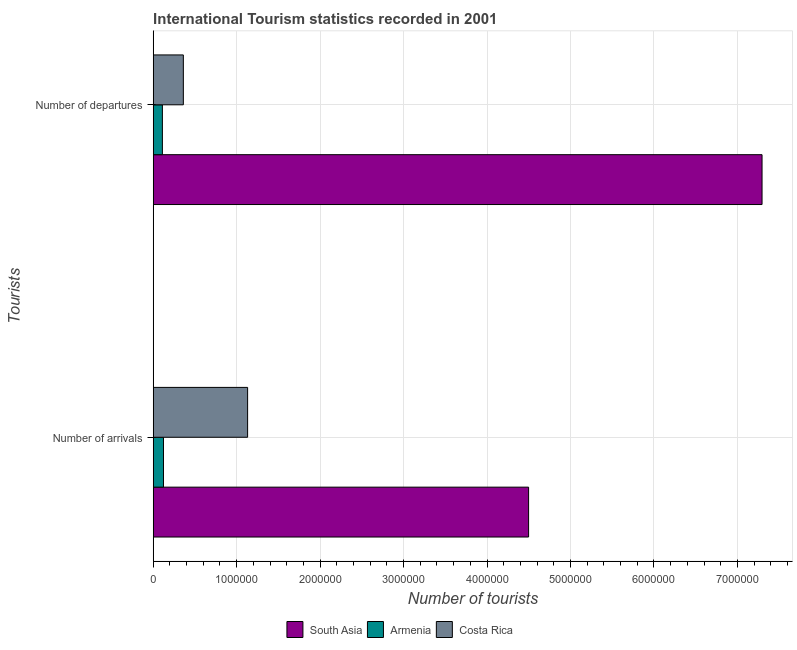Are the number of bars on each tick of the Y-axis equal?
Offer a terse response. Yes. How many bars are there on the 1st tick from the top?
Provide a succinct answer. 3. How many bars are there on the 1st tick from the bottom?
Provide a succinct answer. 3. What is the label of the 1st group of bars from the top?
Your response must be concise. Number of departures. What is the number of tourist arrivals in South Asia?
Offer a terse response. 4.50e+06. Across all countries, what is the maximum number of tourist departures?
Offer a terse response. 7.29e+06. Across all countries, what is the minimum number of tourist arrivals?
Your response must be concise. 1.23e+05. In which country was the number of tourist departures maximum?
Your response must be concise. South Asia. In which country was the number of tourist arrivals minimum?
Provide a succinct answer. Armenia. What is the total number of tourist arrivals in the graph?
Give a very brief answer. 5.75e+06. What is the difference between the number of tourist departures in Costa Rica and that in Armenia?
Make the answer very short. 2.51e+05. What is the difference between the number of tourist arrivals in Costa Rica and the number of tourist departures in South Asia?
Offer a very short reply. -6.16e+06. What is the average number of tourist departures per country?
Make the answer very short. 2.59e+06. What is the difference between the number of tourist departures and number of tourist arrivals in Armenia?
Make the answer very short. -1.30e+04. What is the ratio of the number of tourist arrivals in Costa Rica to that in Armenia?
Make the answer very short. 9.2. Is the number of tourist departures in Costa Rica less than that in Armenia?
Make the answer very short. No. In how many countries, is the number of tourist arrivals greater than the average number of tourist arrivals taken over all countries?
Your response must be concise. 1. What does the 2nd bar from the top in Number of arrivals represents?
Your answer should be very brief. Armenia. How many bars are there?
Ensure brevity in your answer.  6. Are all the bars in the graph horizontal?
Your answer should be compact. Yes. How many countries are there in the graph?
Your answer should be compact. 3. Does the graph contain any zero values?
Your answer should be compact. No. Where does the legend appear in the graph?
Ensure brevity in your answer.  Bottom center. What is the title of the graph?
Your answer should be very brief. International Tourism statistics recorded in 2001. Does "Monaco" appear as one of the legend labels in the graph?
Make the answer very short. No. What is the label or title of the X-axis?
Give a very brief answer. Number of tourists. What is the label or title of the Y-axis?
Provide a short and direct response. Tourists. What is the Number of tourists of South Asia in Number of arrivals?
Offer a terse response. 4.50e+06. What is the Number of tourists of Armenia in Number of arrivals?
Your answer should be compact. 1.23e+05. What is the Number of tourists of Costa Rica in Number of arrivals?
Make the answer very short. 1.13e+06. What is the Number of tourists in South Asia in Number of departures?
Your answer should be compact. 7.29e+06. What is the Number of tourists in Costa Rica in Number of departures?
Offer a terse response. 3.61e+05. Across all Tourists, what is the maximum Number of tourists of South Asia?
Offer a terse response. 7.29e+06. Across all Tourists, what is the maximum Number of tourists of Armenia?
Ensure brevity in your answer.  1.23e+05. Across all Tourists, what is the maximum Number of tourists of Costa Rica?
Keep it short and to the point. 1.13e+06. Across all Tourists, what is the minimum Number of tourists in South Asia?
Your response must be concise. 4.50e+06. Across all Tourists, what is the minimum Number of tourists of Costa Rica?
Ensure brevity in your answer.  3.61e+05. What is the total Number of tourists in South Asia in the graph?
Your answer should be very brief. 1.18e+07. What is the total Number of tourists in Armenia in the graph?
Give a very brief answer. 2.33e+05. What is the total Number of tourists in Costa Rica in the graph?
Make the answer very short. 1.49e+06. What is the difference between the Number of tourists of South Asia in Number of arrivals and that in Number of departures?
Your answer should be very brief. -2.80e+06. What is the difference between the Number of tourists in Armenia in Number of arrivals and that in Number of departures?
Make the answer very short. 1.30e+04. What is the difference between the Number of tourists of Costa Rica in Number of arrivals and that in Number of departures?
Keep it short and to the point. 7.70e+05. What is the difference between the Number of tourists of South Asia in Number of arrivals and the Number of tourists of Armenia in Number of departures?
Your response must be concise. 4.39e+06. What is the difference between the Number of tourists of South Asia in Number of arrivals and the Number of tourists of Costa Rica in Number of departures?
Give a very brief answer. 4.14e+06. What is the difference between the Number of tourists in Armenia in Number of arrivals and the Number of tourists in Costa Rica in Number of departures?
Your answer should be compact. -2.38e+05. What is the average Number of tourists of South Asia per Tourists?
Your answer should be very brief. 5.90e+06. What is the average Number of tourists in Armenia per Tourists?
Your answer should be compact. 1.16e+05. What is the average Number of tourists of Costa Rica per Tourists?
Keep it short and to the point. 7.46e+05. What is the difference between the Number of tourists of South Asia and Number of tourists of Armenia in Number of arrivals?
Keep it short and to the point. 4.37e+06. What is the difference between the Number of tourists in South Asia and Number of tourists in Costa Rica in Number of arrivals?
Make the answer very short. 3.37e+06. What is the difference between the Number of tourists in Armenia and Number of tourists in Costa Rica in Number of arrivals?
Provide a short and direct response. -1.01e+06. What is the difference between the Number of tourists in South Asia and Number of tourists in Armenia in Number of departures?
Your answer should be compact. 7.18e+06. What is the difference between the Number of tourists in South Asia and Number of tourists in Costa Rica in Number of departures?
Give a very brief answer. 6.93e+06. What is the difference between the Number of tourists in Armenia and Number of tourists in Costa Rica in Number of departures?
Provide a succinct answer. -2.51e+05. What is the ratio of the Number of tourists in South Asia in Number of arrivals to that in Number of departures?
Offer a very short reply. 0.62. What is the ratio of the Number of tourists of Armenia in Number of arrivals to that in Number of departures?
Your answer should be compact. 1.12. What is the ratio of the Number of tourists in Costa Rica in Number of arrivals to that in Number of departures?
Offer a terse response. 3.13. What is the difference between the highest and the second highest Number of tourists in South Asia?
Provide a short and direct response. 2.80e+06. What is the difference between the highest and the second highest Number of tourists in Armenia?
Your answer should be very brief. 1.30e+04. What is the difference between the highest and the second highest Number of tourists in Costa Rica?
Make the answer very short. 7.70e+05. What is the difference between the highest and the lowest Number of tourists of South Asia?
Your answer should be compact. 2.80e+06. What is the difference between the highest and the lowest Number of tourists of Armenia?
Your answer should be very brief. 1.30e+04. What is the difference between the highest and the lowest Number of tourists of Costa Rica?
Your answer should be very brief. 7.70e+05. 